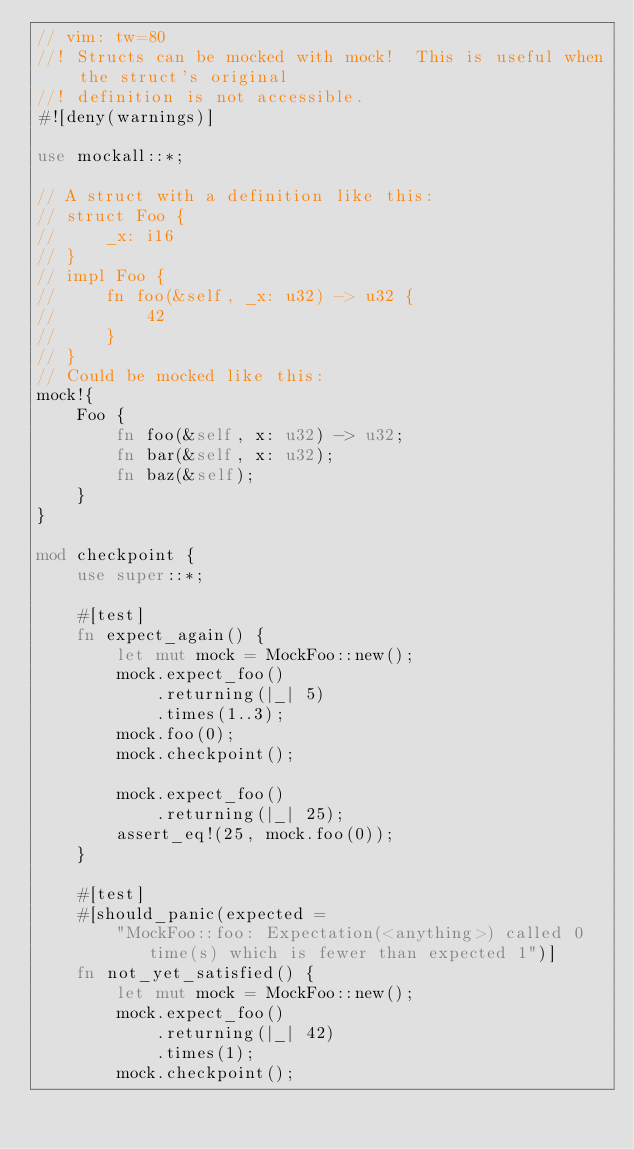<code> <loc_0><loc_0><loc_500><loc_500><_Rust_>// vim: tw=80
//! Structs can be mocked with mock!  This is useful when the struct's original
//! definition is not accessible.
#![deny(warnings)]

use mockall::*;

// A struct with a definition like this:
// struct Foo {
//     _x: i16
// }
// impl Foo {
//     fn foo(&self, _x: u32) -> u32 {
//         42
//     }
// }
// Could be mocked like this:
mock!{
    Foo {
        fn foo(&self, x: u32) -> u32;
        fn bar(&self, x: u32);
        fn baz(&self);
    }
}

mod checkpoint {
    use super::*;

    #[test]
    fn expect_again() {
        let mut mock = MockFoo::new();
        mock.expect_foo()
            .returning(|_| 5)
            .times(1..3);
        mock.foo(0);
        mock.checkpoint();

        mock.expect_foo()
            .returning(|_| 25);
        assert_eq!(25, mock.foo(0));
    }

    #[test]
    #[should_panic(expected =
        "MockFoo::foo: Expectation(<anything>) called 0 time(s) which is fewer than expected 1")]
    fn not_yet_satisfied() {
        let mut mock = MockFoo::new();
        mock.expect_foo()
            .returning(|_| 42)
            .times(1);
        mock.checkpoint();</code> 